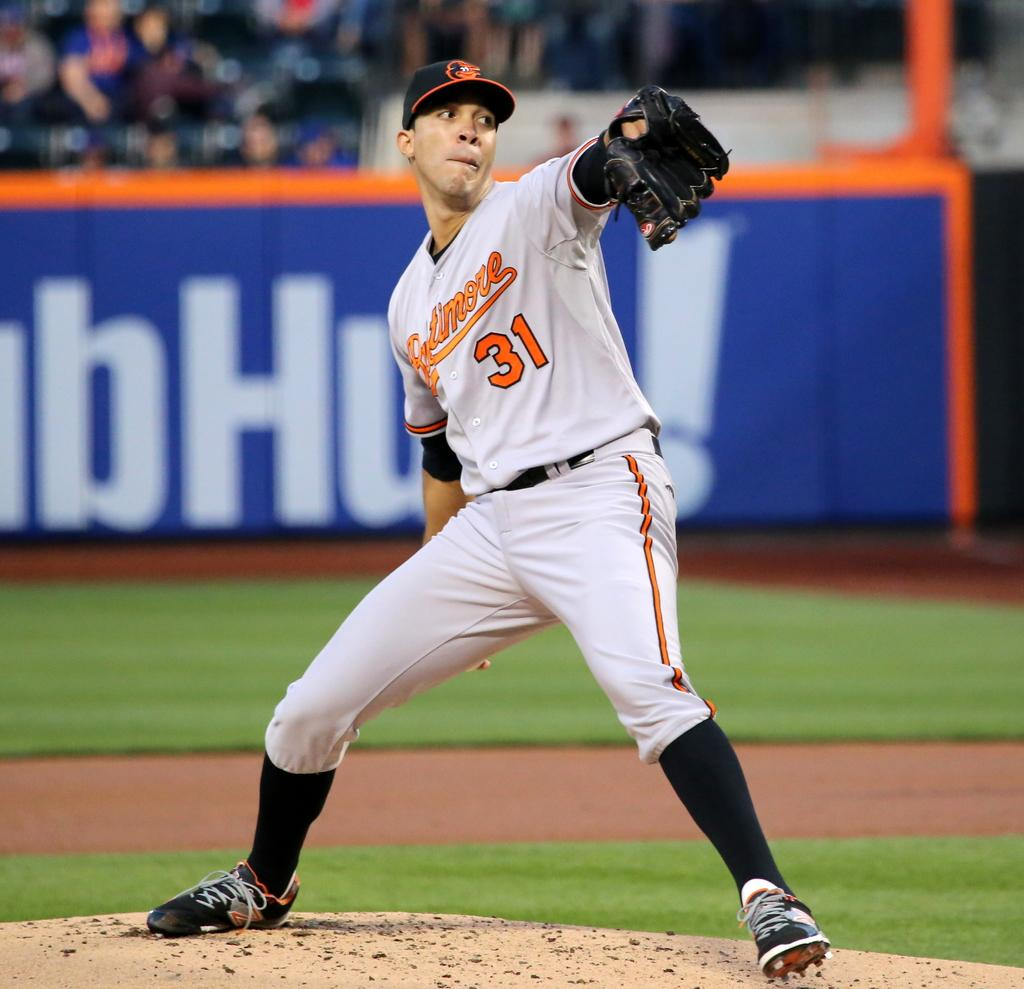Provide a one-sentence caption for the provided image. Player number 31 for Baltimore has his hand back as he prepares to throw the ball. 